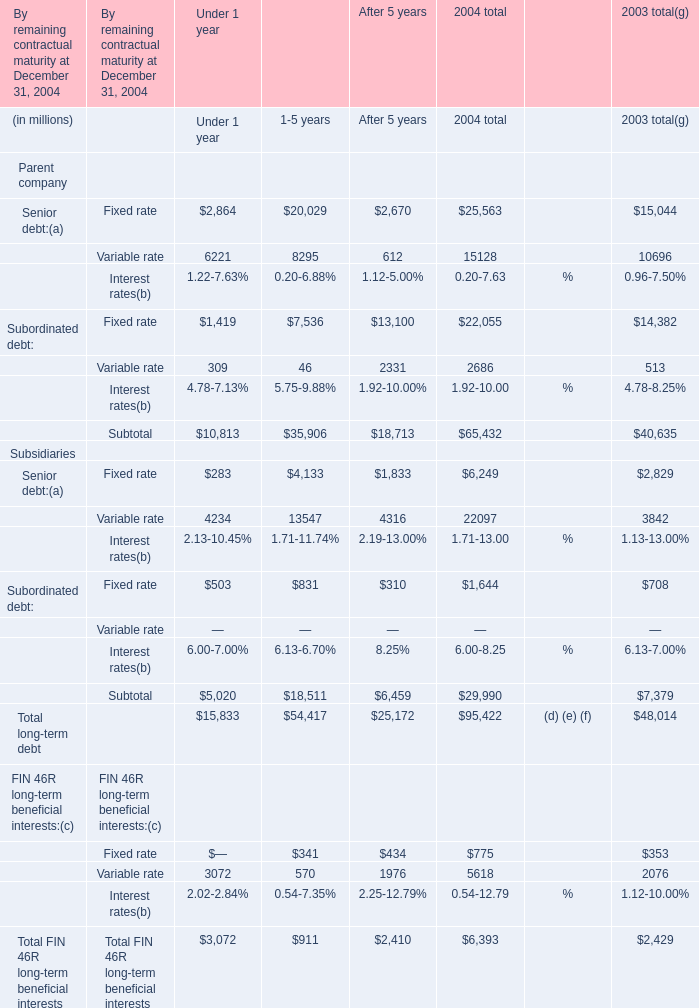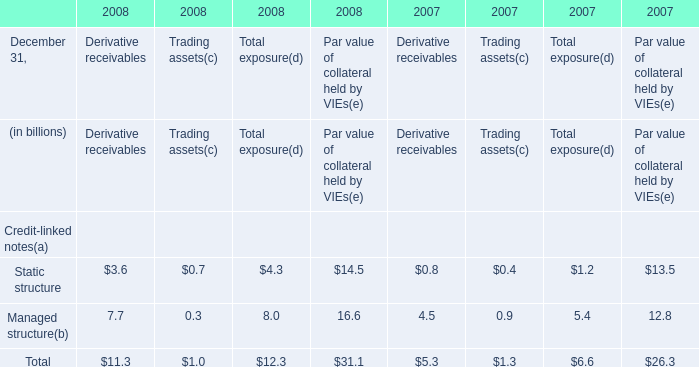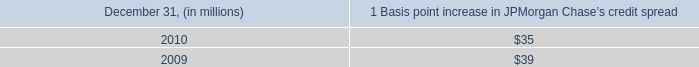What is the sum of Parent company in 2004 total? (in million) 
Computations: ((((25563 + 15128) + 22055) + 2686) + 65432)
Answer: 130864.0. 